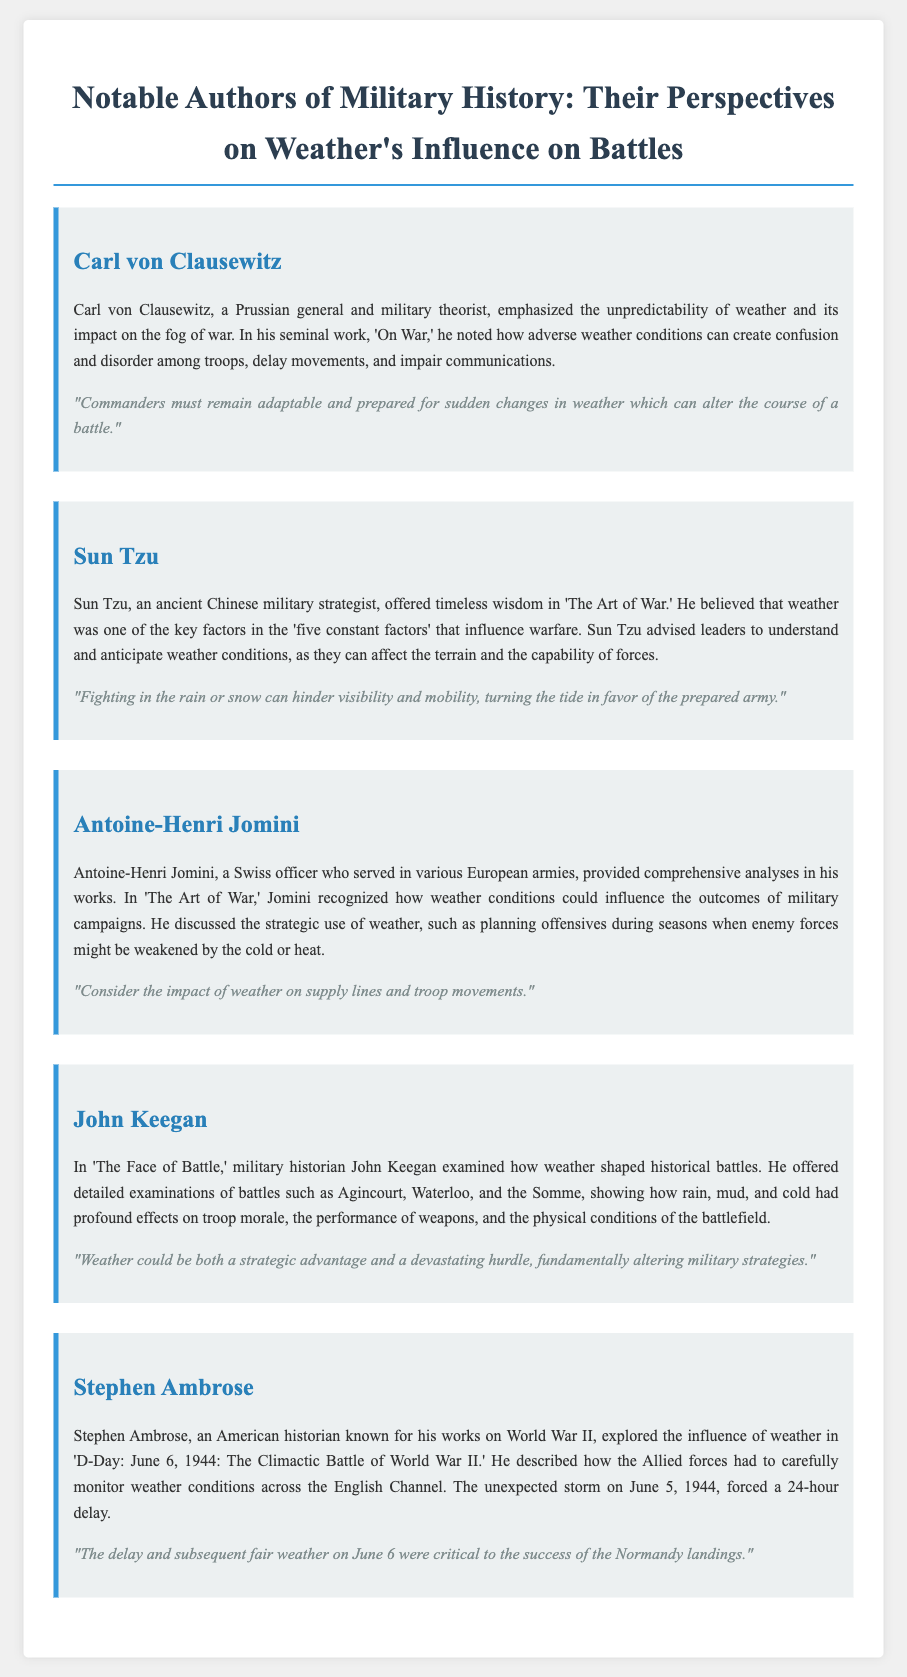What is the title of the document? The title is presented at the top of the document, summarizing its focus on military history and weather's influence on battles.
Answer: Weather's Influence on Military History Who wrote 'On War'? The author is listed in the document as a Prussian general and military theorist, emphasizing his significant contribution to military theory.
Answer: Carl von Clausewitz What is one key factor in warfare according to Sun Tzu? The document mentions Sun Tzu's view on weather as a crucial element affecting battle outcomes.
Answer: Weather Which battle does John Keegan examine in relation to weather? The document outlines specific historical battles analyzed by Keegan that describe the impact of weather.
Answer: Agincourt What did Stephen Ambrose explore in his work on D-Day? The document states that Ambrose focused on the role of weather conditions during a specific World War II event.
Answer: Weather conditions across the English Channel 